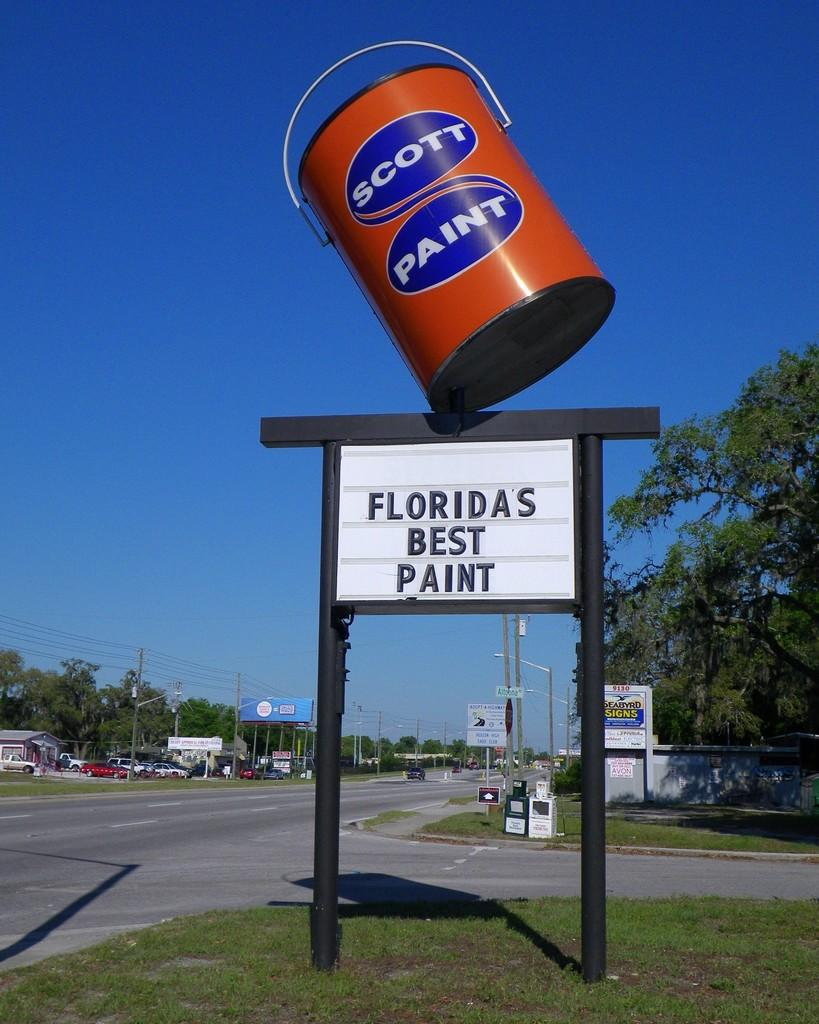<image>
Render a clear and concise summary of the photo. A paint store's sign says that they have Florida's best paint. 